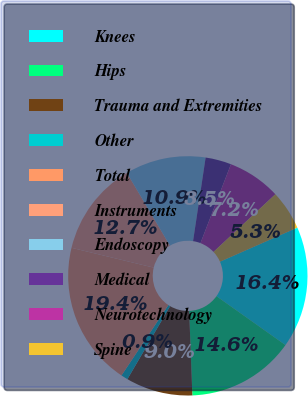<chart> <loc_0><loc_0><loc_500><loc_500><pie_chart><fcel>Knees<fcel>Hips<fcel>Trauma and Extremities<fcel>Other<fcel>Total<fcel>Instruments<fcel>Endoscopy<fcel>Medical<fcel>Neurotechnology<fcel>Spine<nl><fcel>16.42%<fcel>14.58%<fcel>9.03%<fcel>0.93%<fcel>19.41%<fcel>12.73%<fcel>10.88%<fcel>3.49%<fcel>7.19%<fcel>5.34%<nl></chart> 